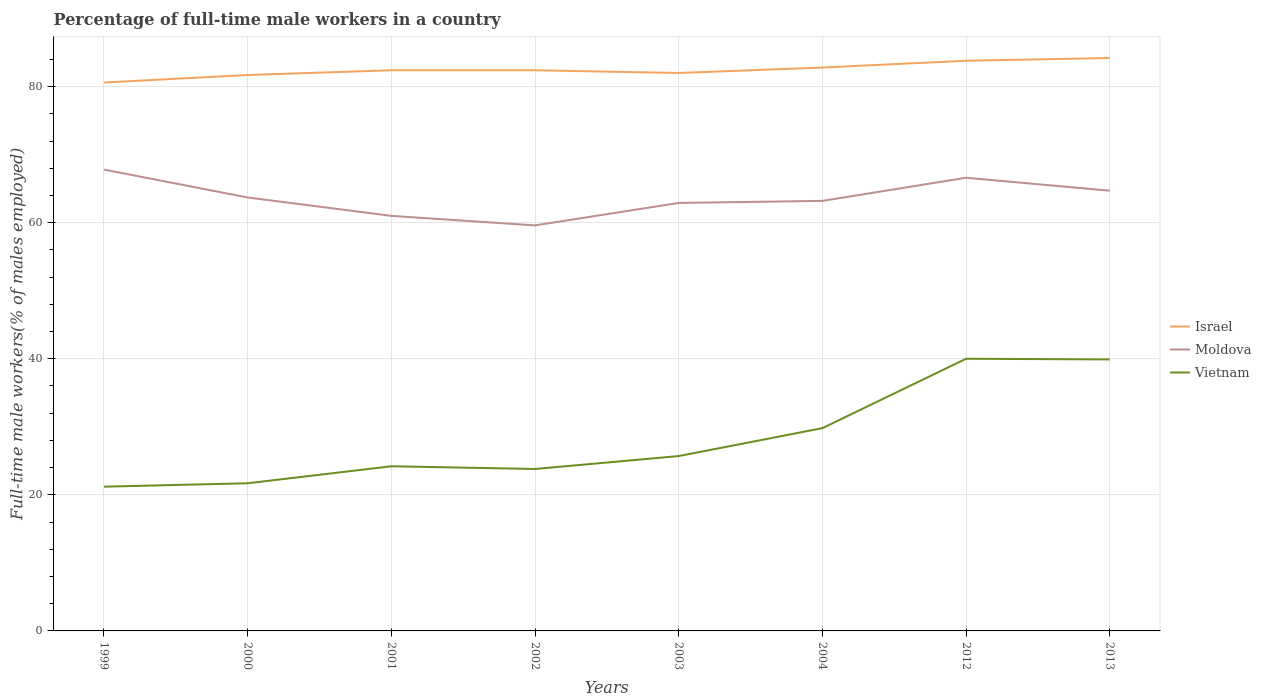Across all years, what is the maximum percentage of full-time male workers in Moldova?
Your answer should be very brief. 59.6. In which year was the percentage of full-time male workers in Vietnam maximum?
Ensure brevity in your answer.  1999. What is the total percentage of full-time male workers in Israel in the graph?
Your answer should be very brief. -1.4. What is the difference between the highest and the second highest percentage of full-time male workers in Moldova?
Your answer should be very brief. 8.2. Is the percentage of full-time male workers in Moldova strictly greater than the percentage of full-time male workers in Vietnam over the years?
Offer a very short reply. No. How many lines are there?
Keep it short and to the point. 3. How many years are there in the graph?
Provide a short and direct response. 8. Are the values on the major ticks of Y-axis written in scientific E-notation?
Offer a very short reply. No. Where does the legend appear in the graph?
Make the answer very short. Center right. What is the title of the graph?
Offer a very short reply. Percentage of full-time male workers in a country. Does "Russian Federation" appear as one of the legend labels in the graph?
Ensure brevity in your answer.  No. What is the label or title of the Y-axis?
Your answer should be compact. Full-time male workers(% of males employed). What is the Full-time male workers(% of males employed) of Israel in 1999?
Make the answer very short. 80.6. What is the Full-time male workers(% of males employed) in Moldova in 1999?
Ensure brevity in your answer.  67.8. What is the Full-time male workers(% of males employed) of Vietnam in 1999?
Ensure brevity in your answer.  21.2. What is the Full-time male workers(% of males employed) of Israel in 2000?
Your response must be concise. 81.7. What is the Full-time male workers(% of males employed) in Moldova in 2000?
Ensure brevity in your answer.  63.7. What is the Full-time male workers(% of males employed) in Vietnam in 2000?
Make the answer very short. 21.7. What is the Full-time male workers(% of males employed) in Israel in 2001?
Provide a short and direct response. 82.4. What is the Full-time male workers(% of males employed) in Moldova in 2001?
Offer a very short reply. 61. What is the Full-time male workers(% of males employed) of Vietnam in 2001?
Provide a short and direct response. 24.2. What is the Full-time male workers(% of males employed) in Israel in 2002?
Ensure brevity in your answer.  82.4. What is the Full-time male workers(% of males employed) in Moldova in 2002?
Offer a terse response. 59.6. What is the Full-time male workers(% of males employed) of Vietnam in 2002?
Make the answer very short. 23.8. What is the Full-time male workers(% of males employed) in Israel in 2003?
Give a very brief answer. 82. What is the Full-time male workers(% of males employed) of Moldova in 2003?
Your answer should be very brief. 62.9. What is the Full-time male workers(% of males employed) in Vietnam in 2003?
Your response must be concise. 25.7. What is the Full-time male workers(% of males employed) of Israel in 2004?
Offer a terse response. 82.8. What is the Full-time male workers(% of males employed) of Moldova in 2004?
Provide a succinct answer. 63.2. What is the Full-time male workers(% of males employed) in Vietnam in 2004?
Your answer should be compact. 29.8. What is the Full-time male workers(% of males employed) of Israel in 2012?
Your answer should be very brief. 83.8. What is the Full-time male workers(% of males employed) of Moldova in 2012?
Ensure brevity in your answer.  66.6. What is the Full-time male workers(% of males employed) in Vietnam in 2012?
Your answer should be compact. 40. What is the Full-time male workers(% of males employed) of Israel in 2013?
Offer a terse response. 84.2. What is the Full-time male workers(% of males employed) of Moldova in 2013?
Offer a terse response. 64.7. What is the Full-time male workers(% of males employed) of Vietnam in 2013?
Your answer should be compact. 39.9. Across all years, what is the maximum Full-time male workers(% of males employed) of Israel?
Provide a succinct answer. 84.2. Across all years, what is the maximum Full-time male workers(% of males employed) in Moldova?
Make the answer very short. 67.8. Across all years, what is the maximum Full-time male workers(% of males employed) of Vietnam?
Provide a succinct answer. 40. Across all years, what is the minimum Full-time male workers(% of males employed) in Israel?
Keep it short and to the point. 80.6. Across all years, what is the minimum Full-time male workers(% of males employed) of Moldova?
Offer a very short reply. 59.6. Across all years, what is the minimum Full-time male workers(% of males employed) in Vietnam?
Keep it short and to the point. 21.2. What is the total Full-time male workers(% of males employed) of Israel in the graph?
Ensure brevity in your answer.  659.9. What is the total Full-time male workers(% of males employed) of Moldova in the graph?
Ensure brevity in your answer.  509.5. What is the total Full-time male workers(% of males employed) in Vietnam in the graph?
Give a very brief answer. 226.3. What is the difference between the Full-time male workers(% of males employed) in Vietnam in 1999 and that in 2000?
Make the answer very short. -0.5. What is the difference between the Full-time male workers(% of males employed) of Israel in 1999 and that in 2001?
Keep it short and to the point. -1.8. What is the difference between the Full-time male workers(% of males employed) of Israel in 1999 and that in 2002?
Keep it short and to the point. -1.8. What is the difference between the Full-time male workers(% of males employed) in Moldova in 1999 and that in 2002?
Offer a terse response. 8.2. What is the difference between the Full-time male workers(% of males employed) in Vietnam in 1999 and that in 2002?
Make the answer very short. -2.6. What is the difference between the Full-time male workers(% of males employed) of Moldova in 1999 and that in 2003?
Your answer should be very brief. 4.9. What is the difference between the Full-time male workers(% of males employed) in Israel in 1999 and that in 2004?
Your response must be concise. -2.2. What is the difference between the Full-time male workers(% of males employed) in Vietnam in 1999 and that in 2004?
Your response must be concise. -8.6. What is the difference between the Full-time male workers(% of males employed) in Moldova in 1999 and that in 2012?
Offer a very short reply. 1.2. What is the difference between the Full-time male workers(% of males employed) of Vietnam in 1999 and that in 2012?
Offer a terse response. -18.8. What is the difference between the Full-time male workers(% of males employed) in Vietnam in 1999 and that in 2013?
Provide a short and direct response. -18.7. What is the difference between the Full-time male workers(% of males employed) of Vietnam in 2000 and that in 2001?
Ensure brevity in your answer.  -2.5. What is the difference between the Full-time male workers(% of males employed) of Israel in 2000 and that in 2002?
Give a very brief answer. -0.7. What is the difference between the Full-time male workers(% of males employed) in Moldova in 2000 and that in 2002?
Keep it short and to the point. 4.1. What is the difference between the Full-time male workers(% of males employed) in Israel in 2000 and that in 2003?
Ensure brevity in your answer.  -0.3. What is the difference between the Full-time male workers(% of males employed) in Vietnam in 2000 and that in 2003?
Your answer should be compact. -4. What is the difference between the Full-time male workers(% of males employed) in Vietnam in 2000 and that in 2012?
Ensure brevity in your answer.  -18.3. What is the difference between the Full-time male workers(% of males employed) in Vietnam in 2000 and that in 2013?
Give a very brief answer. -18.2. What is the difference between the Full-time male workers(% of males employed) of Moldova in 2001 and that in 2002?
Offer a very short reply. 1.4. What is the difference between the Full-time male workers(% of males employed) of Vietnam in 2001 and that in 2002?
Keep it short and to the point. 0.4. What is the difference between the Full-time male workers(% of males employed) of Israel in 2001 and that in 2003?
Your answer should be compact. 0.4. What is the difference between the Full-time male workers(% of males employed) in Vietnam in 2001 and that in 2003?
Provide a short and direct response. -1.5. What is the difference between the Full-time male workers(% of males employed) in Moldova in 2001 and that in 2004?
Offer a very short reply. -2.2. What is the difference between the Full-time male workers(% of males employed) in Vietnam in 2001 and that in 2004?
Give a very brief answer. -5.6. What is the difference between the Full-time male workers(% of males employed) in Israel in 2001 and that in 2012?
Provide a short and direct response. -1.4. What is the difference between the Full-time male workers(% of males employed) of Moldova in 2001 and that in 2012?
Make the answer very short. -5.6. What is the difference between the Full-time male workers(% of males employed) in Vietnam in 2001 and that in 2012?
Keep it short and to the point. -15.8. What is the difference between the Full-time male workers(% of males employed) in Moldova in 2001 and that in 2013?
Your answer should be very brief. -3.7. What is the difference between the Full-time male workers(% of males employed) in Vietnam in 2001 and that in 2013?
Provide a short and direct response. -15.7. What is the difference between the Full-time male workers(% of males employed) of Moldova in 2002 and that in 2003?
Your response must be concise. -3.3. What is the difference between the Full-time male workers(% of males employed) in Vietnam in 2002 and that in 2003?
Keep it short and to the point. -1.9. What is the difference between the Full-time male workers(% of males employed) of Moldova in 2002 and that in 2004?
Offer a very short reply. -3.6. What is the difference between the Full-time male workers(% of males employed) in Israel in 2002 and that in 2012?
Make the answer very short. -1.4. What is the difference between the Full-time male workers(% of males employed) of Moldova in 2002 and that in 2012?
Your answer should be compact. -7. What is the difference between the Full-time male workers(% of males employed) of Vietnam in 2002 and that in 2012?
Your answer should be very brief. -16.2. What is the difference between the Full-time male workers(% of males employed) of Israel in 2002 and that in 2013?
Your answer should be very brief. -1.8. What is the difference between the Full-time male workers(% of males employed) of Vietnam in 2002 and that in 2013?
Ensure brevity in your answer.  -16.1. What is the difference between the Full-time male workers(% of males employed) of Moldova in 2003 and that in 2004?
Offer a terse response. -0.3. What is the difference between the Full-time male workers(% of males employed) of Vietnam in 2003 and that in 2004?
Keep it short and to the point. -4.1. What is the difference between the Full-time male workers(% of males employed) of Israel in 2003 and that in 2012?
Your answer should be very brief. -1.8. What is the difference between the Full-time male workers(% of males employed) in Vietnam in 2003 and that in 2012?
Your response must be concise. -14.3. What is the difference between the Full-time male workers(% of males employed) in Israel in 2003 and that in 2013?
Your answer should be compact. -2.2. What is the difference between the Full-time male workers(% of males employed) of Moldova in 2003 and that in 2013?
Provide a short and direct response. -1.8. What is the difference between the Full-time male workers(% of males employed) in Israel in 2004 and that in 2013?
Provide a short and direct response. -1.4. What is the difference between the Full-time male workers(% of males employed) of Moldova in 2004 and that in 2013?
Your answer should be very brief. -1.5. What is the difference between the Full-time male workers(% of males employed) in Israel in 2012 and that in 2013?
Keep it short and to the point. -0.4. What is the difference between the Full-time male workers(% of males employed) of Israel in 1999 and the Full-time male workers(% of males employed) of Moldova in 2000?
Offer a very short reply. 16.9. What is the difference between the Full-time male workers(% of males employed) of Israel in 1999 and the Full-time male workers(% of males employed) of Vietnam in 2000?
Provide a succinct answer. 58.9. What is the difference between the Full-time male workers(% of males employed) of Moldova in 1999 and the Full-time male workers(% of males employed) of Vietnam in 2000?
Offer a terse response. 46.1. What is the difference between the Full-time male workers(% of males employed) in Israel in 1999 and the Full-time male workers(% of males employed) in Moldova in 2001?
Give a very brief answer. 19.6. What is the difference between the Full-time male workers(% of males employed) in Israel in 1999 and the Full-time male workers(% of males employed) in Vietnam in 2001?
Your response must be concise. 56.4. What is the difference between the Full-time male workers(% of males employed) in Moldova in 1999 and the Full-time male workers(% of males employed) in Vietnam in 2001?
Offer a very short reply. 43.6. What is the difference between the Full-time male workers(% of males employed) of Israel in 1999 and the Full-time male workers(% of males employed) of Vietnam in 2002?
Your answer should be compact. 56.8. What is the difference between the Full-time male workers(% of males employed) in Moldova in 1999 and the Full-time male workers(% of males employed) in Vietnam in 2002?
Offer a terse response. 44. What is the difference between the Full-time male workers(% of males employed) of Israel in 1999 and the Full-time male workers(% of males employed) of Moldova in 2003?
Keep it short and to the point. 17.7. What is the difference between the Full-time male workers(% of males employed) of Israel in 1999 and the Full-time male workers(% of males employed) of Vietnam in 2003?
Your response must be concise. 54.9. What is the difference between the Full-time male workers(% of males employed) of Moldova in 1999 and the Full-time male workers(% of males employed) of Vietnam in 2003?
Your answer should be very brief. 42.1. What is the difference between the Full-time male workers(% of males employed) in Israel in 1999 and the Full-time male workers(% of males employed) in Vietnam in 2004?
Keep it short and to the point. 50.8. What is the difference between the Full-time male workers(% of males employed) of Israel in 1999 and the Full-time male workers(% of males employed) of Moldova in 2012?
Offer a terse response. 14. What is the difference between the Full-time male workers(% of males employed) in Israel in 1999 and the Full-time male workers(% of males employed) in Vietnam in 2012?
Your answer should be compact. 40.6. What is the difference between the Full-time male workers(% of males employed) in Moldova in 1999 and the Full-time male workers(% of males employed) in Vietnam in 2012?
Offer a very short reply. 27.8. What is the difference between the Full-time male workers(% of males employed) of Israel in 1999 and the Full-time male workers(% of males employed) of Moldova in 2013?
Provide a succinct answer. 15.9. What is the difference between the Full-time male workers(% of males employed) in Israel in 1999 and the Full-time male workers(% of males employed) in Vietnam in 2013?
Give a very brief answer. 40.7. What is the difference between the Full-time male workers(% of males employed) in Moldova in 1999 and the Full-time male workers(% of males employed) in Vietnam in 2013?
Your answer should be very brief. 27.9. What is the difference between the Full-time male workers(% of males employed) of Israel in 2000 and the Full-time male workers(% of males employed) of Moldova in 2001?
Your response must be concise. 20.7. What is the difference between the Full-time male workers(% of males employed) of Israel in 2000 and the Full-time male workers(% of males employed) of Vietnam in 2001?
Provide a short and direct response. 57.5. What is the difference between the Full-time male workers(% of males employed) of Moldova in 2000 and the Full-time male workers(% of males employed) of Vietnam in 2001?
Provide a succinct answer. 39.5. What is the difference between the Full-time male workers(% of males employed) of Israel in 2000 and the Full-time male workers(% of males employed) of Moldova in 2002?
Keep it short and to the point. 22.1. What is the difference between the Full-time male workers(% of males employed) of Israel in 2000 and the Full-time male workers(% of males employed) of Vietnam in 2002?
Offer a very short reply. 57.9. What is the difference between the Full-time male workers(% of males employed) of Moldova in 2000 and the Full-time male workers(% of males employed) of Vietnam in 2002?
Your answer should be very brief. 39.9. What is the difference between the Full-time male workers(% of males employed) of Israel in 2000 and the Full-time male workers(% of males employed) of Moldova in 2003?
Your answer should be compact. 18.8. What is the difference between the Full-time male workers(% of males employed) in Israel in 2000 and the Full-time male workers(% of males employed) in Vietnam in 2003?
Provide a short and direct response. 56. What is the difference between the Full-time male workers(% of males employed) of Israel in 2000 and the Full-time male workers(% of males employed) of Moldova in 2004?
Offer a very short reply. 18.5. What is the difference between the Full-time male workers(% of males employed) of Israel in 2000 and the Full-time male workers(% of males employed) of Vietnam in 2004?
Give a very brief answer. 51.9. What is the difference between the Full-time male workers(% of males employed) of Moldova in 2000 and the Full-time male workers(% of males employed) of Vietnam in 2004?
Ensure brevity in your answer.  33.9. What is the difference between the Full-time male workers(% of males employed) in Israel in 2000 and the Full-time male workers(% of males employed) in Vietnam in 2012?
Ensure brevity in your answer.  41.7. What is the difference between the Full-time male workers(% of males employed) in Moldova in 2000 and the Full-time male workers(% of males employed) in Vietnam in 2012?
Give a very brief answer. 23.7. What is the difference between the Full-time male workers(% of males employed) of Israel in 2000 and the Full-time male workers(% of males employed) of Moldova in 2013?
Make the answer very short. 17. What is the difference between the Full-time male workers(% of males employed) of Israel in 2000 and the Full-time male workers(% of males employed) of Vietnam in 2013?
Offer a very short reply. 41.8. What is the difference between the Full-time male workers(% of males employed) of Moldova in 2000 and the Full-time male workers(% of males employed) of Vietnam in 2013?
Provide a succinct answer. 23.8. What is the difference between the Full-time male workers(% of males employed) in Israel in 2001 and the Full-time male workers(% of males employed) in Moldova in 2002?
Your answer should be compact. 22.8. What is the difference between the Full-time male workers(% of males employed) of Israel in 2001 and the Full-time male workers(% of males employed) of Vietnam in 2002?
Your answer should be very brief. 58.6. What is the difference between the Full-time male workers(% of males employed) in Moldova in 2001 and the Full-time male workers(% of males employed) in Vietnam in 2002?
Your answer should be very brief. 37.2. What is the difference between the Full-time male workers(% of males employed) of Israel in 2001 and the Full-time male workers(% of males employed) of Vietnam in 2003?
Keep it short and to the point. 56.7. What is the difference between the Full-time male workers(% of males employed) in Moldova in 2001 and the Full-time male workers(% of males employed) in Vietnam in 2003?
Your response must be concise. 35.3. What is the difference between the Full-time male workers(% of males employed) of Israel in 2001 and the Full-time male workers(% of males employed) of Moldova in 2004?
Ensure brevity in your answer.  19.2. What is the difference between the Full-time male workers(% of males employed) of Israel in 2001 and the Full-time male workers(% of males employed) of Vietnam in 2004?
Ensure brevity in your answer.  52.6. What is the difference between the Full-time male workers(% of males employed) of Moldova in 2001 and the Full-time male workers(% of males employed) of Vietnam in 2004?
Provide a succinct answer. 31.2. What is the difference between the Full-time male workers(% of males employed) in Israel in 2001 and the Full-time male workers(% of males employed) in Vietnam in 2012?
Provide a succinct answer. 42.4. What is the difference between the Full-time male workers(% of males employed) in Israel in 2001 and the Full-time male workers(% of males employed) in Moldova in 2013?
Provide a succinct answer. 17.7. What is the difference between the Full-time male workers(% of males employed) in Israel in 2001 and the Full-time male workers(% of males employed) in Vietnam in 2013?
Offer a terse response. 42.5. What is the difference between the Full-time male workers(% of males employed) of Moldova in 2001 and the Full-time male workers(% of males employed) of Vietnam in 2013?
Offer a very short reply. 21.1. What is the difference between the Full-time male workers(% of males employed) in Israel in 2002 and the Full-time male workers(% of males employed) in Vietnam in 2003?
Your answer should be compact. 56.7. What is the difference between the Full-time male workers(% of males employed) of Moldova in 2002 and the Full-time male workers(% of males employed) of Vietnam in 2003?
Ensure brevity in your answer.  33.9. What is the difference between the Full-time male workers(% of males employed) of Israel in 2002 and the Full-time male workers(% of males employed) of Moldova in 2004?
Ensure brevity in your answer.  19.2. What is the difference between the Full-time male workers(% of males employed) of Israel in 2002 and the Full-time male workers(% of males employed) of Vietnam in 2004?
Keep it short and to the point. 52.6. What is the difference between the Full-time male workers(% of males employed) of Moldova in 2002 and the Full-time male workers(% of males employed) of Vietnam in 2004?
Your response must be concise. 29.8. What is the difference between the Full-time male workers(% of males employed) of Israel in 2002 and the Full-time male workers(% of males employed) of Moldova in 2012?
Ensure brevity in your answer.  15.8. What is the difference between the Full-time male workers(% of males employed) in Israel in 2002 and the Full-time male workers(% of males employed) in Vietnam in 2012?
Ensure brevity in your answer.  42.4. What is the difference between the Full-time male workers(% of males employed) of Moldova in 2002 and the Full-time male workers(% of males employed) of Vietnam in 2012?
Keep it short and to the point. 19.6. What is the difference between the Full-time male workers(% of males employed) of Israel in 2002 and the Full-time male workers(% of males employed) of Vietnam in 2013?
Your answer should be very brief. 42.5. What is the difference between the Full-time male workers(% of males employed) of Moldova in 2002 and the Full-time male workers(% of males employed) of Vietnam in 2013?
Give a very brief answer. 19.7. What is the difference between the Full-time male workers(% of males employed) in Israel in 2003 and the Full-time male workers(% of males employed) in Moldova in 2004?
Make the answer very short. 18.8. What is the difference between the Full-time male workers(% of males employed) of Israel in 2003 and the Full-time male workers(% of males employed) of Vietnam in 2004?
Ensure brevity in your answer.  52.2. What is the difference between the Full-time male workers(% of males employed) of Moldova in 2003 and the Full-time male workers(% of males employed) of Vietnam in 2004?
Give a very brief answer. 33.1. What is the difference between the Full-time male workers(% of males employed) in Israel in 2003 and the Full-time male workers(% of males employed) in Moldova in 2012?
Provide a succinct answer. 15.4. What is the difference between the Full-time male workers(% of males employed) in Moldova in 2003 and the Full-time male workers(% of males employed) in Vietnam in 2012?
Provide a short and direct response. 22.9. What is the difference between the Full-time male workers(% of males employed) in Israel in 2003 and the Full-time male workers(% of males employed) in Vietnam in 2013?
Offer a terse response. 42.1. What is the difference between the Full-time male workers(% of males employed) of Moldova in 2003 and the Full-time male workers(% of males employed) of Vietnam in 2013?
Provide a succinct answer. 23. What is the difference between the Full-time male workers(% of males employed) in Israel in 2004 and the Full-time male workers(% of males employed) in Vietnam in 2012?
Your response must be concise. 42.8. What is the difference between the Full-time male workers(% of males employed) in Moldova in 2004 and the Full-time male workers(% of males employed) in Vietnam in 2012?
Ensure brevity in your answer.  23.2. What is the difference between the Full-time male workers(% of males employed) of Israel in 2004 and the Full-time male workers(% of males employed) of Moldova in 2013?
Provide a succinct answer. 18.1. What is the difference between the Full-time male workers(% of males employed) in Israel in 2004 and the Full-time male workers(% of males employed) in Vietnam in 2013?
Make the answer very short. 42.9. What is the difference between the Full-time male workers(% of males employed) in Moldova in 2004 and the Full-time male workers(% of males employed) in Vietnam in 2013?
Provide a succinct answer. 23.3. What is the difference between the Full-time male workers(% of males employed) in Israel in 2012 and the Full-time male workers(% of males employed) in Vietnam in 2013?
Offer a terse response. 43.9. What is the difference between the Full-time male workers(% of males employed) in Moldova in 2012 and the Full-time male workers(% of males employed) in Vietnam in 2013?
Ensure brevity in your answer.  26.7. What is the average Full-time male workers(% of males employed) in Israel per year?
Ensure brevity in your answer.  82.49. What is the average Full-time male workers(% of males employed) in Moldova per year?
Ensure brevity in your answer.  63.69. What is the average Full-time male workers(% of males employed) of Vietnam per year?
Give a very brief answer. 28.29. In the year 1999, what is the difference between the Full-time male workers(% of males employed) of Israel and Full-time male workers(% of males employed) of Moldova?
Keep it short and to the point. 12.8. In the year 1999, what is the difference between the Full-time male workers(% of males employed) in Israel and Full-time male workers(% of males employed) in Vietnam?
Give a very brief answer. 59.4. In the year 1999, what is the difference between the Full-time male workers(% of males employed) in Moldova and Full-time male workers(% of males employed) in Vietnam?
Your answer should be very brief. 46.6. In the year 2000, what is the difference between the Full-time male workers(% of males employed) of Israel and Full-time male workers(% of males employed) of Moldova?
Make the answer very short. 18. In the year 2000, what is the difference between the Full-time male workers(% of males employed) of Israel and Full-time male workers(% of males employed) of Vietnam?
Provide a succinct answer. 60. In the year 2001, what is the difference between the Full-time male workers(% of males employed) in Israel and Full-time male workers(% of males employed) in Moldova?
Give a very brief answer. 21.4. In the year 2001, what is the difference between the Full-time male workers(% of males employed) of Israel and Full-time male workers(% of males employed) of Vietnam?
Provide a succinct answer. 58.2. In the year 2001, what is the difference between the Full-time male workers(% of males employed) in Moldova and Full-time male workers(% of males employed) in Vietnam?
Your answer should be very brief. 36.8. In the year 2002, what is the difference between the Full-time male workers(% of males employed) of Israel and Full-time male workers(% of males employed) of Moldova?
Ensure brevity in your answer.  22.8. In the year 2002, what is the difference between the Full-time male workers(% of males employed) in Israel and Full-time male workers(% of males employed) in Vietnam?
Offer a terse response. 58.6. In the year 2002, what is the difference between the Full-time male workers(% of males employed) of Moldova and Full-time male workers(% of males employed) of Vietnam?
Provide a short and direct response. 35.8. In the year 2003, what is the difference between the Full-time male workers(% of males employed) in Israel and Full-time male workers(% of males employed) in Vietnam?
Provide a short and direct response. 56.3. In the year 2003, what is the difference between the Full-time male workers(% of males employed) in Moldova and Full-time male workers(% of males employed) in Vietnam?
Provide a short and direct response. 37.2. In the year 2004, what is the difference between the Full-time male workers(% of males employed) of Israel and Full-time male workers(% of males employed) of Moldova?
Keep it short and to the point. 19.6. In the year 2004, what is the difference between the Full-time male workers(% of males employed) in Moldova and Full-time male workers(% of males employed) in Vietnam?
Give a very brief answer. 33.4. In the year 2012, what is the difference between the Full-time male workers(% of males employed) of Israel and Full-time male workers(% of males employed) of Vietnam?
Make the answer very short. 43.8. In the year 2012, what is the difference between the Full-time male workers(% of males employed) of Moldova and Full-time male workers(% of males employed) of Vietnam?
Your answer should be very brief. 26.6. In the year 2013, what is the difference between the Full-time male workers(% of males employed) in Israel and Full-time male workers(% of males employed) in Moldova?
Offer a very short reply. 19.5. In the year 2013, what is the difference between the Full-time male workers(% of males employed) of Israel and Full-time male workers(% of males employed) of Vietnam?
Ensure brevity in your answer.  44.3. In the year 2013, what is the difference between the Full-time male workers(% of males employed) of Moldova and Full-time male workers(% of males employed) of Vietnam?
Offer a very short reply. 24.8. What is the ratio of the Full-time male workers(% of males employed) in Israel in 1999 to that in 2000?
Offer a very short reply. 0.99. What is the ratio of the Full-time male workers(% of males employed) in Moldova in 1999 to that in 2000?
Make the answer very short. 1.06. What is the ratio of the Full-time male workers(% of males employed) of Israel in 1999 to that in 2001?
Provide a succinct answer. 0.98. What is the ratio of the Full-time male workers(% of males employed) in Moldova in 1999 to that in 2001?
Give a very brief answer. 1.11. What is the ratio of the Full-time male workers(% of males employed) in Vietnam in 1999 to that in 2001?
Your answer should be compact. 0.88. What is the ratio of the Full-time male workers(% of males employed) in Israel in 1999 to that in 2002?
Provide a succinct answer. 0.98. What is the ratio of the Full-time male workers(% of males employed) in Moldova in 1999 to that in 2002?
Your response must be concise. 1.14. What is the ratio of the Full-time male workers(% of males employed) of Vietnam in 1999 to that in 2002?
Provide a short and direct response. 0.89. What is the ratio of the Full-time male workers(% of males employed) in Israel in 1999 to that in 2003?
Your response must be concise. 0.98. What is the ratio of the Full-time male workers(% of males employed) in Moldova in 1999 to that in 2003?
Your answer should be compact. 1.08. What is the ratio of the Full-time male workers(% of males employed) in Vietnam in 1999 to that in 2003?
Keep it short and to the point. 0.82. What is the ratio of the Full-time male workers(% of males employed) of Israel in 1999 to that in 2004?
Offer a very short reply. 0.97. What is the ratio of the Full-time male workers(% of males employed) of Moldova in 1999 to that in 2004?
Your answer should be very brief. 1.07. What is the ratio of the Full-time male workers(% of males employed) of Vietnam in 1999 to that in 2004?
Make the answer very short. 0.71. What is the ratio of the Full-time male workers(% of males employed) in Israel in 1999 to that in 2012?
Ensure brevity in your answer.  0.96. What is the ratio of the Full-time male workers(% of males employed) of Vietnam in 1999 to that in 2012?
Your response must be concise. 0.53. What is the ratio of the Full-time male workers(% of males employed) of Israel in 1999 to that in 2013?
Your answer should be compact. 0.96. What is the ratio of the Full-time male workers(% of males employed) of Moldova in 1999 to that in 2013?
Your answer should be very brief. 1.05. What is the ratio of the Full-time male workers(% of males employed) in Vietnam in 1999 to that in 2013?
Your response must be concise. 0.53. What is the ratio of the Full-time male workers(% of males employed) of Moldova in 2000 to that in 2001?
Make the answer very short. 1.04. What is the ratio of the Full-time male workers(% of males employed) of Vietnam in 2000 to that in 2001?
Your response must be concise. 0.9. What is the ratio of the Full-time male workers(% of males employed) of Moldova in 2000 to that in 2002?
Offer a terse response. 1.07. What is the ratio of the Full-time male workers(% of males employed) in Vietnam in 2000 to that in 2002?
Keep it short and to the point. 0.91. What is the ratio of the Full-time male workers(% of males employed) in Israel in 2000 to that in 2003?
Your answer should be compact. 1. What is the ratio of the Full-time male workers(% of males employed) of Moldova in 2000 to that in 2003?
Provide a succinct answer. 1.01. What is the ratio of the Full-time male workers(% of males employed) of Vietnam in 2000 to that in 2003?
Give a very brief answer. 0.84. What is the ratio of the Full-time male workers(% of males employed) in Israel in 2000 to that in 2004?
Offer a very short reply. 0.99. What is the ratio of the Full-time male workers(% of males employed) in Moldova in 2000 to that in 2004?
Provide a succinct answer. 1.01. What is the ratio of the Full-time male workers(% of males employed) of Vietnam in 2000 to that in 2004?
Provide a short and direct response. 0.73. What is the ratio of the Full-time male workers(% of males employed) of Israel in 2000 to that in 2012?
Offer a very short reply. 0.97. What is the ratio of the Full-time male workers(% of males employed) of Moldova in 2000 to that in 2012?
Ensure brevity in your answer.  0.96. What is the ratio of the Full-time male workers(% of males employed) in Vietnam in 2000 to that in 2012?
Offer a terse response. 0.54. What is the ratio of the Full-time male workers(% of males employed) of Israel in 2000 to that in 2013?
Keep it short and to the point. 0.97. What is the ratio of the Full-time male workers(% of males employed) of Moldova in 2000 to that in 2013?
Offer a terse response. 0.98. What is the ratio of the Full-time male workers(% of males employed) in Vietnam in 2000 to that in 2013?
Provide a succinct answer. 0.54. What is the ratio of the Full-time male workers(% of males employed) of Israel in 2001 to that in 2002?
Provide a succinct answer. 1. What is the ratio of the Full-time male workers(% of males employed) in Moldova in 2001 to that in 2002?
Keep it short and to the point. 1.02. What is the ratio of the Full-time male workers(% of males employed) of Vietnam in 2001 to that in 2002?
Your answer should be compact. 1.02. What is the ratio of the Full-time male workers(% of males employed) in Moldova in 2001 to that in 2003?
Keep it short and to the point. 0.97. What is the ratio of the Full-time male workers(% of males employed) of Vietnam in 2001 to that in 2003?
Offer a very short reply. 0.94. What is the ratio of the Full-time male workers(% of males employed) of Moldova in 2001 to that in 2004?
Your answer should be very brief. 0.97. What is the ratio of the Full-time male workers(% of males employed) of Vietnam in 2001 to that in 2004?
Your answer should be compact. 0.81. What is the ratio of the Full-time male workers(% of males employed) in Israel in 2001 to that in 2012?
Give a very brief answer. 0.98. What is the ratio of the Full-time male workers(% of males employed) in Moldova in 2001 to that in 2012?
Offer a terse response. 0.92. What is the ratio of the Full-time male workers(% of males employed) of Vietnam in 2001 to that in 2012?
Give a very brief answer. 0.6. What is the ratio of the Full-time male workers(% of males employed) in Israel in 2001 to that in 2013?
Offer a very short reply. 0.98. What is the ratio of the Full-time male workers(% of males employed) in Moldova in 2001 to that in 2013?
Provide a succinct answer. 0.94. What is the ratio of the Full-time male workers(% of males employed) of Vietnam in 2001 to that in 2013?
Your response must be concise. 0.61. What is the ratio of the Full-time male workers(% of males employed) of Moldova in 2002 to that in 2003?
Provide a short and direct response. 0.95. What is the ratio of the Full-time male workers(% of males employed) in Vietnam in 2002 to that in 2003?
Your response must be concise. 0.93. What is the ratio of the Full-time male workers(% of males employed) of Israel in 2002 to that in 2004?
Keep it short and to the point. 1. What is the ratio of the Full-time male workers(% of males employed) of Moldova in 2002 to that in 2004?
Your response must be concise. 0.94. What is the ratio of the Full-time male workers(% of males employed) of Vietnam in 2002 to that in 2004?
Make the answer very short. 0.8. What is the ratio of the Full-time male workers(% of males employed) of Israel in 2002 to that in 2012?
Provide a short and direct response. 0.98. What is the ratio of the Full-time male workers(% of males employed) in Moldova in 2002 to that in 2012?
Provide a succinct answer. 0.89. What is the ratio of the Full-time male workers(% of males employed) of Vietnam in 2002 to that in 2012?
Ensure brevity in your answer.  0.59. What is the ratio of the Full-time male workers(% of males employed) of Israel in 2002 to that in 2013?
Offer a very short reply. 0.98. What is the ratio of the Full-time male workers(% of males employed) of Moldova in 2002 to that in 2013?
Your answer should be compact. 0.92. What is the ratio of the Full-time male workers(% of males employed) in Vietnam in 2002 to that in 2013?
Provide a short and direct response. 0.6. What is the ratio of the Full-time male workers(% of males employed) in Israel in 2003 to that in 2004?
Your answer should be very brief. 0.99. What is the ratio of the Full-time male workers(% of males employed) in Vietnam in 2003 to that in 2004?
Keep it short and to the point. 0.86. What is the ratio of the Full-time male workers(% of males employed) in Israel in 2003 to that in 2012?
Your answer should be compact. 0.98. What is the ratio of the Full-time male workers(% of males employed) in Moldova in 2003 to that in 2012?
Ensure brevity in your answer.  0.94. What is the ratio of the Full-time male workers(% of males employed) in Vietnam in 2003 to that in 2012?
Offer a very short reply. 0.64. What is the ratio of the Full-time male workers(% of males employed) in Israel in 2003 to that in 2013?
Keep it short and to the point. 0.97. What is the ratio of the Full-time male workers(% of males employed) in Moldova in 2003 to that in 2013?
Give a very brief answer. 0.97. What is the ratio of the Full-time male workers(% of males employed) in Vietnam in 2003 to that in 2013?
Ensure brevity in your answer.  0.64. What is the ratio of the Full-time male workers(% of males employed) in Moldova in 2004 to that in 2012?
Provide a short and direct response. 0.95. What is the ratio of the Full-time male workers(% of males employed) in Vietnam in 2004 to that in 2012?
Provide a short and direct response. 0.74. What is the ratio of the Full-time male workers(% of males employed) of Israel in 2004 to that in 2013?
Offer a terse response. 0.98. What is the ratio of the Full-time male workers(% of males employed) in Moldova in 2004 to that in 2013?
Your answer should be compact. 0.98. What is the ratio of the Full-time male workers(% of males employed) of Vietnam in 2004 to that in 2013?
Make the answer very short. 0.75. What is the ratio of the Full-time male workers(% of males employed) of Moldova in 2012 to that in 2013?
Ensure brevity in your answer.  1.03. What is the ratio of the Full-time male workers(% of males employed) in Vietnam in 2012 to that in 2013?
Provide a succinct answer. 1. What is the difference between the highest and the second highest Full-time male workers(% of males employed) of Israel?
Make the answer very short. 0.4. What is the difference between the highest and the lowest Full-time male workers(% of males employed) of Vietnam?
Offer a terse response. 18.8. 